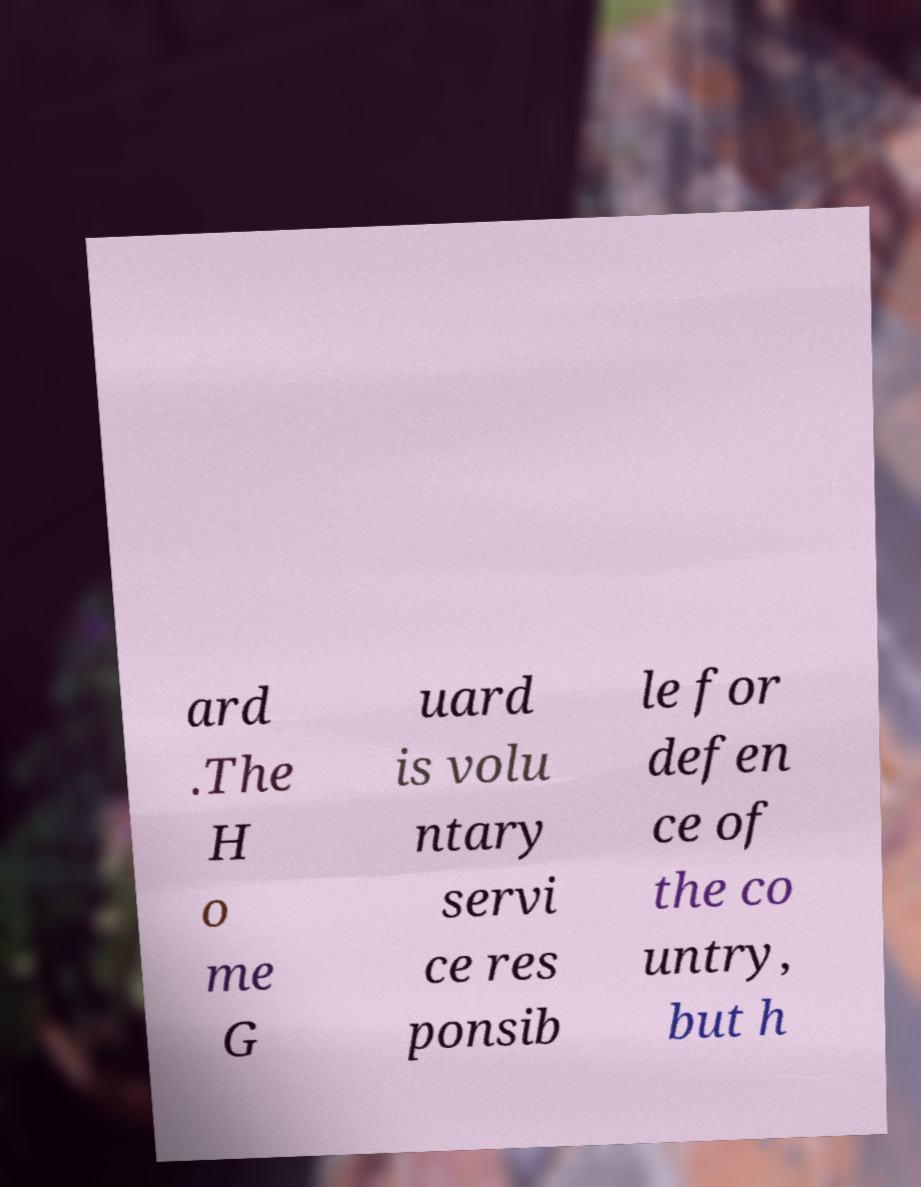Can you accurately transcribe the text from the provided image for me? ard .The H o me G uard is volu ntary servi ce res ponsib le for defen ce of the co untry, but h 